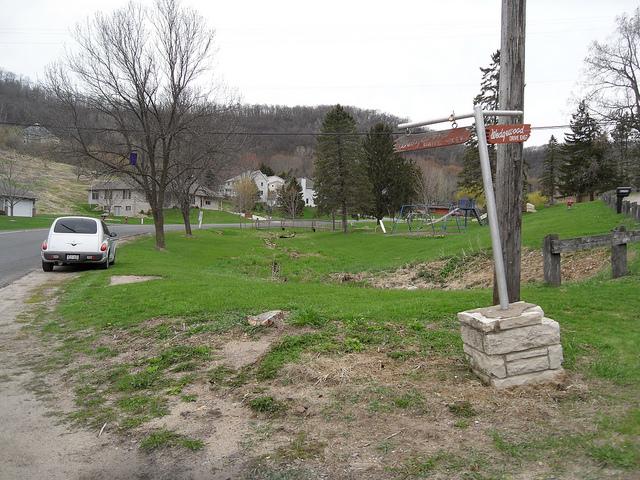Where are all the people?
Keep it brief. Home. Are there leaves on all of the trees?
Give a very brief answer. No. How many cars are there?
Keep it brief. 1. Is this a countryside?
Quick response, please. Yes. 